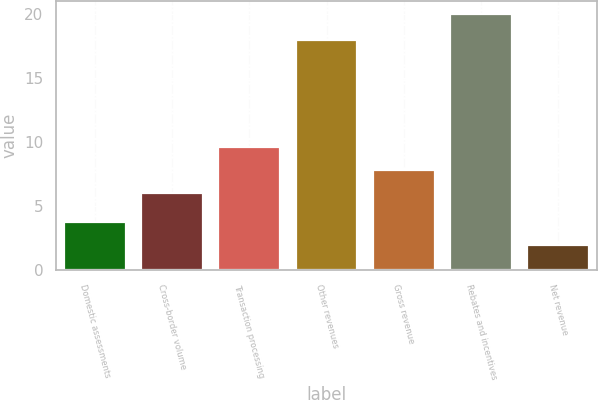<chart> <loc_0><loc_0><loc_500><loc_500><bar_chart><fcel>Domestic assessments<fcel>Cross-border volume<fcel>Transaction processing<fcel>Other revenues<fcel>Gross revenue<fcel>Rebates and incentives<fcel>Net revenue<nl><fcel>3.8<fcel>6<fcel>9.6<fcel>18<fcel>7.8<fcel>20<fcel>2<nl></chart> 